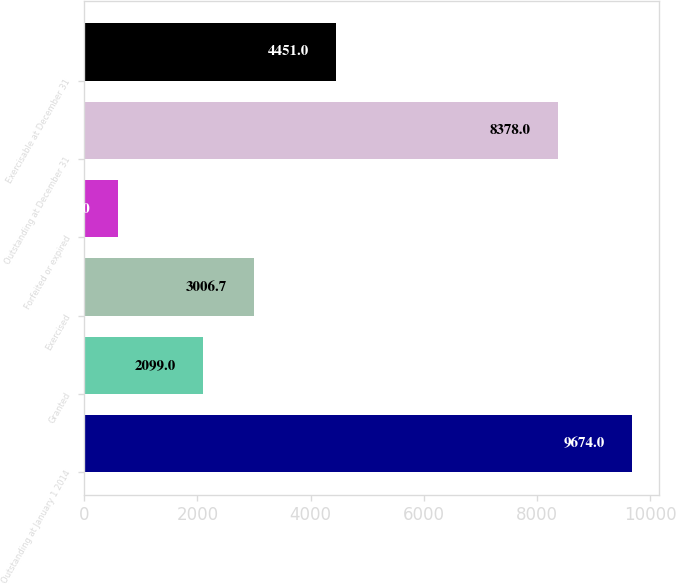Convert chart. <chart><loc_0><loc_0><loc_500><loc_500><bar_chart><fcel>Outstanding at January 1 2014<fcel>Granted<fcel>Exercised<fcel>Forfeited or expired<fcel>Outstanding at December 31<fcel>Exercisable at December 31<nl><fcel>9674<fcel>2099<fcel>3006.7<fcel>597<fcel>8378<fcel>4451<nl></chart> 